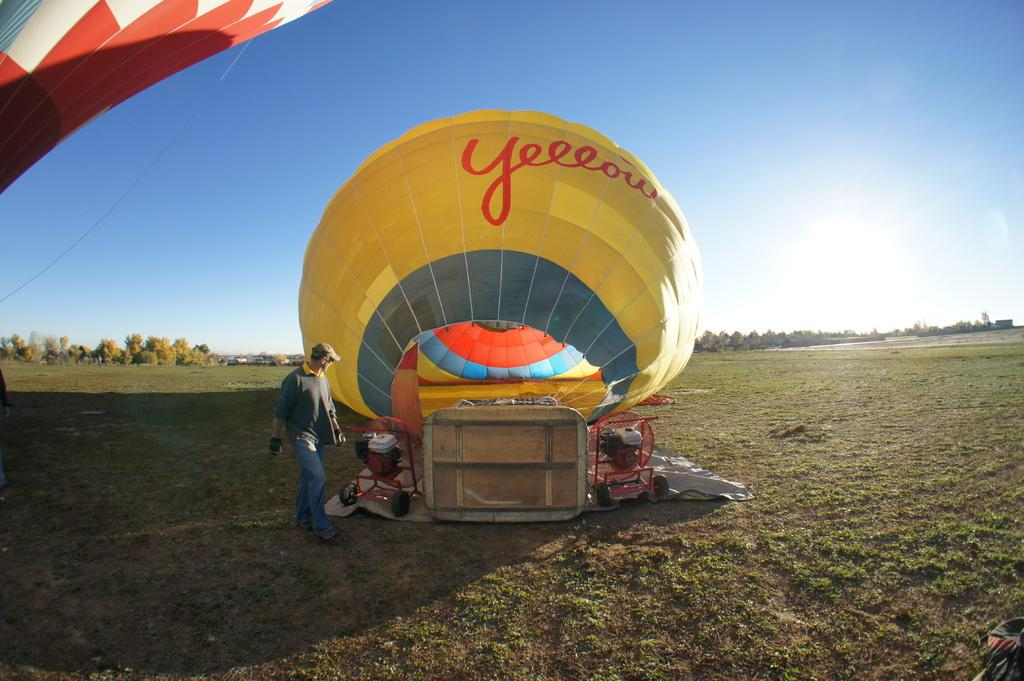What type of equipment can be seen in the image? There are parachutes and machines in the image. What is the person in the image doing? The person is walking on the ground in the image. What can be seen in the background of the image? There are trees and the sky visible in the background of the image. How many beds are arranged in the image? There are no beds present in the image. What type of airport can be seen in the image? There is no airport depicted in the image. What kind of field is visible in the image? There is no field present in the image. 